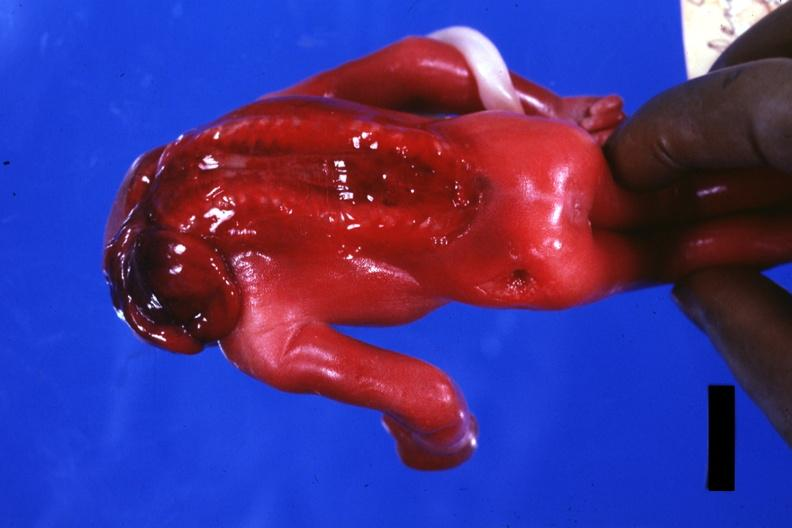what does this image show?
Answer the question using a single word or phrase. Posterior view open cord 